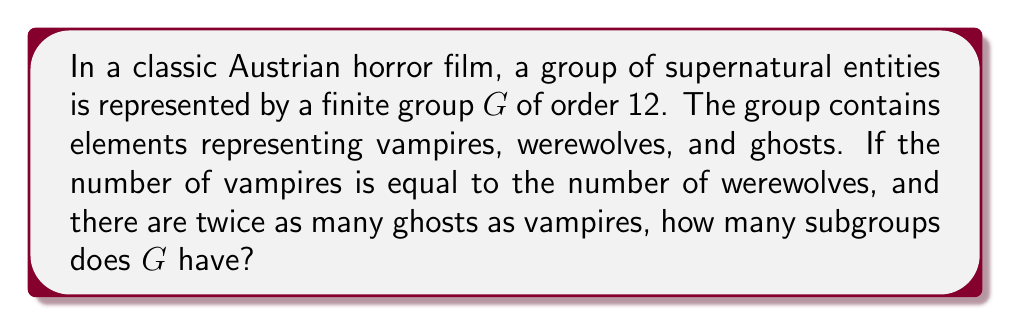Show me your answer to this math problem. Let's approach this step-by-step:

1) First, we need to determine the structure of the group $G$. Given the information:
   - $|G| = 12$
   - Number of vampires = Number of werewolves
   - Number of ghosts = 2 × Number of vampires

2) Let $x$ be the number of vampires (and werewolves). Then:
   $x + x + 2x = 12$
   $4x = 12$
   $x = 3$

3) So, the group consists of 3 vampires, 3 werewolves, and 6 ghosts.

4) The only group of order 12 with this structure is $A_4$, the alternating group on 4 elements.

5) Now, we need to find the number of subgroups of $A_4$. The subgroups of $A_4$ are:
   - The trivial subgroup $\{e\}$
   - Four subgroups of order 3 (corresponding to the 3-cycles)
   - Three subgroups of order 2 (corresponding to the products of two disjoint transpositions)
   - One subgroup of order 4 (the Klein four-group)
   - The whole group $A_4$

6) Therefore, the total number of subgroups is:
   $1 + 4 + 3 + 1 + 1 = 10$

This result is consistent with the skeptical nature of the Austrian horror fan, as it provides a concrete mathematical structure to the supernatural entities, potentially demystifying them.
Answer: The group $G$ has 10 subgroups. 